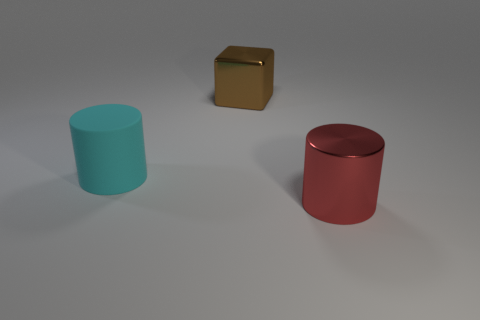Add 2 brown metallic objects. How many objects exist? 5 Subtract all cubes. How many objects are left? 2 Subtract all large cyan rubber cylinders. Subtract all big matte objects. How many objects are left? 1 Add 1 brown objects. How many brown objects are left? 2 Add 3 big red cylinders. How many big red cylinders exist? 4 Subtract 0 brown cylinders. How many objects are left? 3 